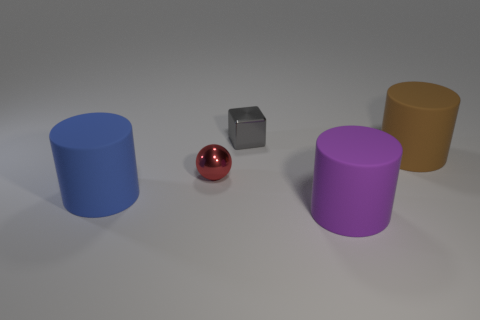Subtract all big blue cylinders. How many cylinders are left? 2 Subtract all purple cylinders. How many cylinders are left? 2 Add 4 large red metal cylinders. How many objects exist? 9 Subtract all balls. How many objects are left? 4 Add 5 red things. How many red things are left? 6 Add 3 large gray metal balls. How many large gray metal balls exist? 3 Subtract 0 brown balls. How many objects are left? 5 Subtract all gray cylinders. Subtract all red cubes. How many cylinders are left? 3 Subtract all blue spheres. How many yellow cylinders are left? 0 Subtract all purple things. Subtract all big matte objects. How many objects are left? 1 